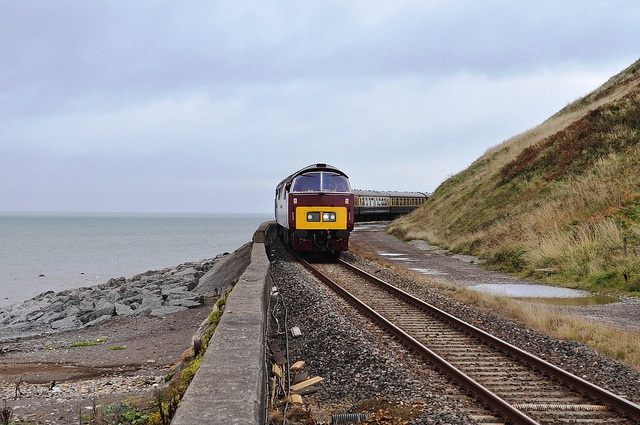Describe the objects in this image and their specific colors. I can see a train in lavender, black, gray, darkgray, and lightgray tones in this image. 